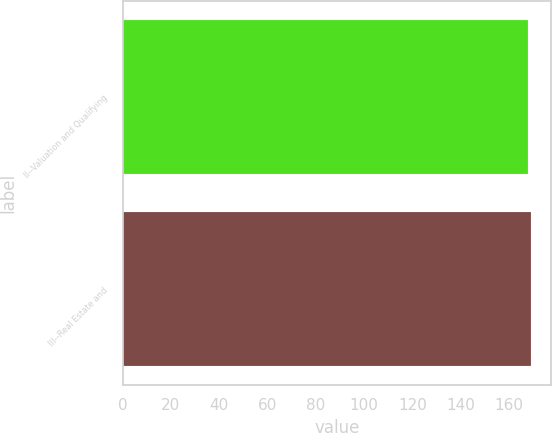<chart> <loc_0><loc_0><loc_500><loc_500><bar_chart><fcel>II--Valuation and Qualifying<fcel>III--Real Estate and<nl><fcel>168<fcel>169<nl></chart> 